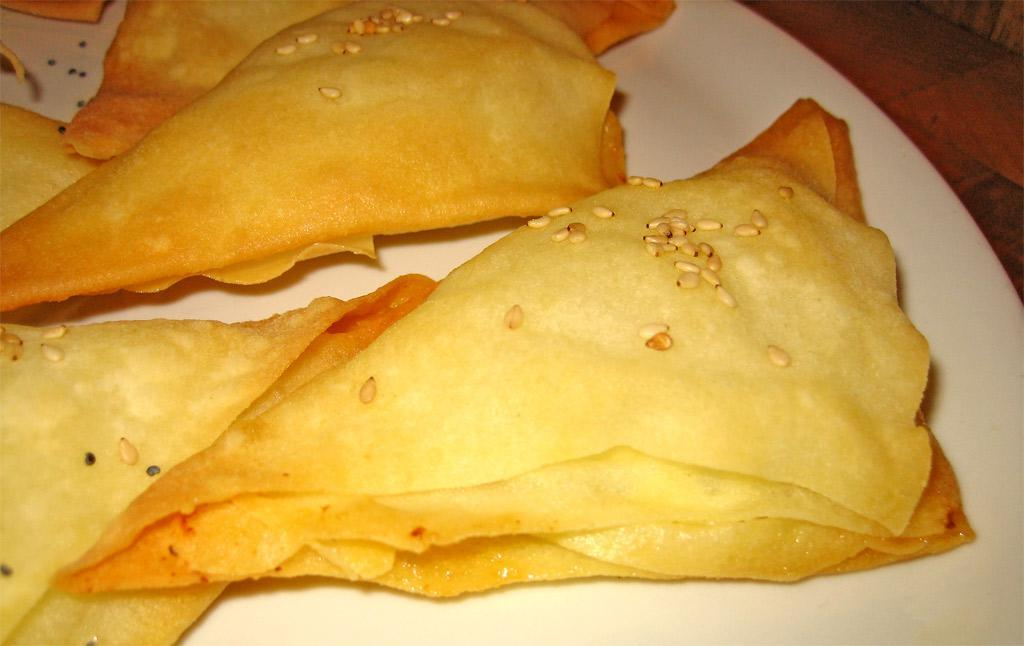What is on the plate that is visible in the image? There is food on a plate in the image. Where is the plate located in the image? The plate is placed on a surface in the image. What type of wood is the chair made of in the image? There is no chair present in the image, so it is not possible to determine the type of wood it might be made of. 